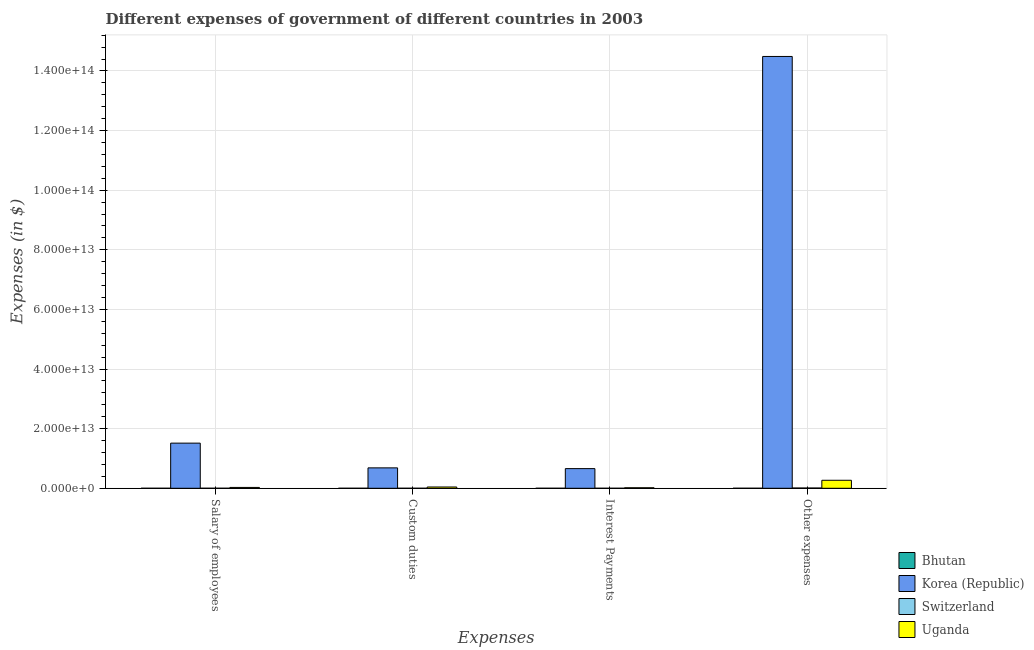How many different coloured bars are there?
Your answer should be compact. 4. Are the number of bars per tick equal to the number of legend labels?
Keep it short and to the point. Yes. How many bars are there on the 4th tick from the left?
Your answer should be compact. 4. How many bars are there on the 1st tick from the right?
Ensure brevity in your answer.  4. What is the label of the 4th group of bars from the left?
Your response must be concise. Other expenses. What is the amount spent on other expenses in Switzerland?
Offer a terse response. 8.66e+1. Across all countries, what is the maximum amount spent on salary of employees?
Keep it short and to the point. 1.51e+13. Across all countries, what is the minimum amount spent on salary of employees?
Provide a short and direct response. 1.95e+09. In which country was the amount spent on custom duties minimum?
Give a very brief answer. Bhutan. What is the total amount spent on custom duties in the graph?
Offer a very short reply. 7.28e+12. What is the difference between the amount spent on interest payments in Bhutan and that in Switzerland?
Provide a succinct answer. -3.12e+09. What is the difference between the amount spent on custom duties in Bhutan and the amount spent on salary of employees in Uganda?
Your response must be concise. -2.85e+11. What is the average amount spent on custom duties per country?
Your answer should be compact. 1.82e+12. What is the difference between the amount spent on interest payments and amount spent on other expenses in Bhutan?
Ensure brevity in your answer.  -5.20e+09. What is the ratio of the amount spent on other expenses in Korea (Republic) to that in Switzerland?
Ensure brevity in your answer.  1672.6. Is the amount spent on interest payments in Bhutan less than that in Korea (Republic)?
Keep it short and to the point. Yes. What is the difference between the highest and the second highest amount spent on salary of employees?
Give a very brief answer. 1.49e+13. What is the difference between the highest and the lowest amount spent on other expenses?
Offer a very short reply. 1.45e+14. Is the sum of the amount spent on salary of employees in Korea (Republic) and Bhutan greater than the maximum amount spent on custom duties across all countries?
Your response must be concise. Yes. What does the 3rd bar from the left in Other expenses represents?
Provide a succinct answer. Switzerland. What does the 2nd bar from the right in Other expenses represents?
Your answer should be very brief. Switzerland. How many bars are there?
Provide a short and direct response. 16. Are all the bars in the graph horizontal?
Provide a short and direct response. No. What is the difference between two consecutive major ticks on the Y-axis?
Your response must be concise. 2.00e+13. Are the values on the major ticks of Y-axis written in scientific E-notation?
Ensure brevity in your answer.  Yes. Does the graph contain grids?
Your answer should be very brief. Yes. Where does the legend appear in the graph?
Your response must be concise. Bottom right. How are the legend labels stacked?
Keep it short and to the point. Vertical. What is the title of the graph?
Ensure brevity in your answer.  Different expenses of government of different countries in 2003. Does "Lao PDR" appear as one of the legend labels in the graph?
Keep it short and to the point. No. What is the label or title of the X-axis?
Your answer should be compact. Expenses. What is the label or title of the Y-axis?
Provide a short and direct response. Expenses (in $). What is the Expenses (in $) in Bhutan in Salary of employees?
Offer a terse response. 1.95e+09. What is the Expenses (in $) in Korea (Republic) in Salary of employees?
Give a very brief answer. 1.51e+13. What is the Expenses (in $) of Switzerland in Salary of employees?
Your answer should be very brief. 5.68e+09. What is the Expenses (in $) of Uganda in Salary of employees?
Offer a terse response. 2.85e+11. What is the Expenses (in $) of Bhutan in Custom duties?
Give a very brief answer. 1.15e+08. What is the Expenses (in $) in Korea (Republic) in Custom duties?
Your response must be concise. 6.85e+12. What is the Expenses (in $) of Switzerland in Custom duties?
Offer a terse response. 9.75e+08. What is the Expenses (in $) in Uganda in Custom duties?
Your answer should be very brief. 4.30e+11. What is the Expenses (in $) in Bhutan in Interest Payments?
Provide a short and direct response. 1.69e+08. What is the Expenses (in $) in Korea (Republic) in Interest Payments?
Offer a terse response. 6.60e+12. What is the Expenses (in $) in Switzerland in Interest Payments?
Keep it short and to the point. 3.29e+09. What is the Expenses (in $) of Uganda in Interest Payments?
Provide a short and direct response. 1.74e+11. What is the Expenses (in $) in Bhutan in Other expenses?
Give a very brief answer. 5.37e+09. What is the Expenses (in $) in Korea (Republic) in Other expenses?
Offer a terse response. 1.45e+14. What is the Expenses (in $) of Switzerland in Other expenses?
Keep it short and to the point. 8.66e+1. What is the Expenses (in $) in Uganda in Other expenses?
Your response must be concise. 2.69e+12. Across all Expenses, what is the maximum Expenses (in $) in Bhutan?
Make the answer very short. 5.37e+09. Across all Expenses, what is the maximum Expenses (in $) of Korea (Republic)?
Your response must be concise. 1.45e+14. Across all Expenses, what is the maximum Expenses (in $) of Switzerland?
Offer a very short reply. 8.66e+1. Across all Expenses, what is the maximum Expenses (in $) of Uganda?
Offer a terse response. 2.69e+12. Across all Expenses, what is the minimum Expenses (in $) of Bhutan?
Offer a very short reply. 1.15e+08. Across all Expenses, what is the minimum Expenses (in $) in Korea (Republic)?
Keep it short and to the point. 6.60e+12. Across all Expenses, what is the minimum Expenses (in $) in Switzerland?
Provide a short and direct response. 9.75e+08. Across all Expenses, what is the minimum Expenses (in $) of Uganda?
Keep it short and to the point. 1.74e+11. What is the total Expenses (in $) in Bhutan in the graph?
Provide a succinct answer. 7.60e+09. What is the total Expenses (in $) of Korea (Republic) in the graph?
Offer a very short reply. 1.73e+14. What is the total Expenses (in $) of Switzerland in the graph?
Give a very brief answer. 9.66e+1. What is the total Expenses (in $) of Uganda in the graph?
Provide a succinct answer. 3.58e+12. What is the difference between the Expenses (in $) in Bhutan in Salary of employees and that in Custom duties?
Provide a short and direct response. 1.83e+09. What is the difference between the Expenses (in $) of Korea (Republic) in Salary of employees and that in Custom duties?
Your answer should be very brief. 8.30e+12. What is the difference between the Expenses (in $) of Switzerland in Salary of employees and that in Custom duties?
Make the answer very short. 4.70e+09. What is the difference between the Expenses (in $) in Uganda in Salary of employees and that in Custom duties?
Ensure brevity in your answer.  -1.45e+11. What is the difference between the Expenses (in $) in Bhutan in Salary of employees and that in Interest Payments?
Ensure brevity in your answer.  1.78e+09. What is the difference between the Expenses (in $) in Korea (Republic) in Salary of employees and that in Interest Payments?
Give a very brief answer. 8.55e+12. What is the difference between the Expenses (in $) of Switzerland in Salary of employees and that in Interest Payments?
Keep it short and to the point. 2.38e+09. What is the difference between the Expenses (in $) of Uganda in Salary of employees and that in Interest Payments?
Offer a very short reply. 1.11e+11. What is the difference between the Expenses (in $) in Bhutan in Salary of employees and that in Other expenses?
Give a very brief answer. -3.43e+09. What is the difference between the Expenses (in $) of Korea (Republic) in Salary of employees and that in Other expenses?
Make the answer very short. -1.30e+14. What is the difference between the Expenses (in $) in Switzerland in Salary of employees and that in Other expenses?
Your response must be concise. -8.09e+1. What is the difference between the Expenses (in $) of Uganda in Salary of employees and that in Other expenses?
Offer a very short reply. -2.40e+12. What is the difference between the Expenses (in $) of Bhutan in Custom duties and that in Interest Payments?
Offer a very short reply. -5.37e+07. What is the difference between the Expenses (in $) of Korea (Republic) in Custom duties and that in Interest Payments?
Ensure brevity in your answer.  2.50e+11. What is the difference between the Expenses (in $) in Switzerland in Custom duties and that in Interest Payments?
Your answer should be very brief. -2.32e+09. What is the difference between the Expenses (in $) of Uganda in Custom duties and that in Interest Payments?
Ensure brevity in your answer.  2.56e+11. What is the difference between the Expenses (in $) of Bhutan in Custom duties and that in Other expenses?
Give a very brief answer. -5.26e+09. What is the difference between the Expenses (in $) in Korea (Republic) in Custom duties and that in Other expenses?
Keep it short and to the point. -1.38e+14. What is the difference between the Expenses (in $) in Switzerland in Custom duties and that in Other expenses?
Offer a very short reply. -8.56e+1. What is the difference between the Expenses (in $) of Uganda in Custom duties and that in Other expenses?
Give a very brief answer. -2.26e+12. What is the difference between the Expenses (in $) in Bhutan in Interest Payments and that in Other expenses?
Keep it short and to the point. -5.20e+09. What is the difference between the Expenses (in $) of Korea (Republic) in Interest Payments and that in Other expenses?
Give a very brief answer. -1.38e+14. What is the difference between the Expenses (in $) of Switzerland in Interest Payments and that in Other expenses?
Ensure brevity in your answer.  -8.33e+1. What is the difference between the Expenses (in $) of Uganda in Interest Payments and that in Other expenses?
Offer a very short reply. -2.51e+12. What is the difference between the Expenses (in $) of Bhutan in Salary of employees and the Expenses (in $) of Korea (Republic) in Custom duties?
Your answer should be compact. -6.85e+12. What is the difference between the Expenses (in $) in Bhutan in Salary of employees and the Expenses (in $) in Switzerland in Custom duties?
Offer a very short reply. 9.72e+08. What is the difference between the Expenses (in $) of Bhutan in Salary of employees and the Expenses (in $) of Uganda in Custom duties?
Offer a very short reply. -4.28e+11. What is the difference between the Expenses (in $) in Korea (Republic) in Salary of employees and the Expenses (in $) in Switzerland in Custom duties?
Your answer should be compact. 1.51e+13. What is the difference between the Expenses (in $) of Korea (Republic) in Salary of employees and the Expenses (in $) of Uganda in Custom duties?
Provide a succinct answer. 1.47e+13. What is the difference between the Expenses (in $) in Switzerland in Salary of employees and the Expenses (in $) in Uganda in Custom duties?
Your answer should be very brief. -4.24e+11. What is the difference between the Expenses (in $) in Bhutan in Salary of employees and the Expenses (in $) in Korea (Republic) in Interest Payments?
Keep it short and to the point. -6.60e+12. What is the difference between the Expenses (in $) in Bhutan in Salary of employees and the Expenses (in $) in Switzerland in Interest Payments?
Your response must be concise. -1.35e+09. What is the difference between the Expenses (in $) in Bhutan in Salary of employees and the Expenses (in $) in Uganda in Interest Payments?
Offer a terse response. -1.72e+11. What is the difference between the Expenses (in $) in Korea (Republic) in Salary of employees and the Expenses (in $) in Switzerland in Interest Payments?
Provide a short and direct response. 1.51e+13. What is the difference between the Expenses (in $) in Korea (Republic) in Salary of employees and the Expenses (in $) in Uganda in Interest Payments?
Your answer should be compact. 1.50e+13. What is the difference between the Expenses (in $) in Switzerland in Salary of employees and the Expenses (in $) in Uganda in Interest Payments?
Provide a short and direct response. -1.68e+11. What is the difference between the Expenses (in $) in Bhutan in Salary of employees and the Expenses (in $) in Korea (Republic) in Other expenses?
Your response must be concise. -1.45e+14. What is the difference between the Expenses (in $) of Bhutan in Salary of employees and the Expenses (in $) of Switzerland in Other expenses?
Ensure brevity in your answer.  -8.47e+1. What is the difference between the Expenses (in $) in Bhutan in Salary of employees and the Expenses (in $) in Uganda in Other expenses?
Offer a terse response. -2.69e+12. What is the difference between the Expenses (in $) in Korea (Republic) in Salary of employees and the Expenses (in $) in Switzerland in Other expenses?
Provide a succinct answer. 1.51e+13. What is the difference between the Expenses (in $) in Korea (Republic) in Salary of employees and the Expenses (in $) in Uganda in Other expenses?
Keep it short and to the point. 1.25e+13. What is the difference between the Expenses (in $) of Switzerland in Salary of employees and the Expenses (in $) of Uganda in Other expenses?
Your answer should be compact. -2.68e+12. What is the difference between the Expenses (in $) of Bhutan in Custom duties and the Expenses (in $) of Korea (Republic) in Interest Payments?
Keep it short and to the point. -6.60e+12. What is the difference between the Expenses (in $) of Bhutan in Custom duties and the Expenses (in $) of Switzerland in Interest Payments?
Make the answer very short. -3.18e+09. What is the difference between the Expenses (in $) of Bhutan in Custom duties and the Expenses (in $) of Uganda in Interest Payments?
Your answer should be very brief. -1.74e+11. What is the difference between the Expenses (in $) in Korea (Republic) in Custom duties and the Expenses (in $) in Switzerland in Interest Payments?
Make the answer very short. 6.84e+12. What is the difference between the Expenses (in $) in Korea (Republic) in Custom duties and the Expenses (in $) in Uganda in Interest Payments?
Keep it short and to the point. 6.67e+12. What is the difference between the Expenses (in $) in Switzerland in Custom duties and the Expenses (in $) in Uganda in Interest Payments?
Keep it short and to the point. -1.73e+11. What is the difference between the Expenses (in $) of Bhutan in Custom duties and the Expenses (in $) of Korea (Republic) in Other expenses?
Ensure brevity in your answer.  -1.45e+14. What is the difference between the Expenses (in $) of Bhutan in Custom duties and the Expenses (in $) of Switzerland in Other expenses?
Provide a short and direct response. -8.65e+1. What is the difference between the Expenses (in $) of Bhutan in Custom duties and the Expenses (in $) of Uganda in Other expenses?
Your answer should be very brief. -2.69e+12. What is the difference between the Expenses (in $) in Korea (Republic) in Custom duties and the Expenses (in $) in Switzerland in Other expenses?
Your answer should be very brief. 6.76e+12. What is the difference between the Expenses (in $) of Korea (Republic) in Custom duties and the Expenses (in $) of Uganda in Other expenses?
Make the answer very short. 4.16e+12. What is the difference between the Expenses (in $) of Switzerland in Custom duties and the Expenses (in $) of Uganda in Other expenses?
Ensure brevity in your answer.  -2.69e+12. What is the difference between the Expenses (in $) of Bhutan in Interest Payments and the Expenses (in $) of Korea (Republic) in Other expenses?
Your answer should be compact. -1.45e+14. What is the difference between the Expenses (in $) of Bhutan in Interest Payments and the Expenses (in $) of Switzerland in Other expenses?
Your response must be concise. -8.64e+1. What is the difference between the Expenses (in $) in Bhutan in Interest Payments and the Expenses (in $) in Uganda in Other expenses?
Your response must be concise. -2.69e+12. What is the difference between the Expenses (in $) in Korea (Republic) in Interest Payments and the Expenses (in $) in Switzerland in Other expenses?
Keep it short and to the point. 6.51e+12. What is the difference between the Expenses (in $) of Korea (Republic) in Interest Payments and the Expenses (in $) of Uganda in Other expenses?
Give a very brief answer. 3.91e+12. What is the difference between the Expenses (in $) in Switzerland in Interest Payments and the Expenses (in $) in Uganda in Other expenses?
Your answer should be compact. -2.68e+12. What is the average Expenses (in $) in Bhutan per Expenses?
Offer a terse response. 1.90e+09. What is the average Expenses (in $) in Korea (Republic) per Expenses?
Give a very brief answer. 4.34e+13. What is the average Expenses (in $) of Switzerland per Expenses?
Make the answer very short. 2.41e+1. What is the average Expenses (in $) of Uganda per Expenses?
Offer a terse response. 8.94e+11. What is the difference between the Expenses (in $) of Bhutan and Expenses (in $) of Korea (Republic) in Salary of employees?
Give a very brief answer. -1.51e+13. What is the difference between the Expenses (in $) in Bhutan and Expenses (in $) in Switzerland in Salary of employees?
Keep it short and to the point. -3.73e+09. What is the difference between the Expenses (in $) of Bhutan and Expenses (in $) of Uganda in Salary of employees?
Your answer should be very brief. -2.83e+11. What is the difference between the Expenses (in $) of Korea (Republic) and Expenses (in $) of Switzerland in Salary of employees?
Provide a short and direct response. 1.51e+13. What is the difference between the Expenses (in $) in Korea (Republic) and Expenses (in $) in Uganda in Salary of employees?
Offer a terse response. 1.49e+13. What is the difference between the Expenses (in $) in Switzerland and Expenses (in $) in Uganda in Salary of employees?
Ensure brevity in your answer.  -2.79e+11. What is the difference between the Expenses (in $) in Bhutan and Expenses (in $) in Korea (Republic) in Custom duties?
Provide a succinct answer. -6.85e+12. What is the difference between the Expenses (in $) of Bhutan and Expenses (in $) of Switzerland in Custom duties?
Your answer should be compact. -8.60e+08. What is the difference between the Expenses (in $) of Bhutan and Expenses (in $) of Uganda in Custom duties?
Your response must be concise. -4.30e+11. What is the difference between the Expenses (in $) in Korea (Republic) and Expenses (in $) in Switzerland in Custom duties?
Provide a short and direct response. 6.85e+12. What is the difference between the Expenses (in $) of Korea (Republic) and Expenses (in $) of Uganda in Custom duties?
Your response must be concise. 6.42e+12. What is the difference between the Expenses (in $) in Switzerland and Expenses (in $) in Uganda in Custom duties?
Ensure brevity in your answer.  -4.29e+11. What is the difference between the Expenses (in $) in Bhutan and Expenses (in $) in Korea (Republic) in Interest Payments?
Give a very brief answer. -6.60e+12. What is the difference between the Expenses (in $) of Bhutan and Expenses (in $) of Switzerland in Interest Payments?
Provide a short and direct response. -3.12e+09. What is the difference between the Expenses (in $) of Bhutan and Expenses (in $) of Uganda in Interest Payments?
Your answer should be compact. -1.74e+11. What is the difference between the Expenses (in $) in Korea (Republic) and Expenses (in $) in Switzerland in Interest Payments?
Keep it short and to the point. 6.59e+12. What is the difference between the Expenses (in $) of Korea (Republic) and Expenses (in $) of Uganda in Interest Payments?
Your answer should be compact. 6.42e+12. What is the difference between the Expenses (in $) of Switzerland and Expenses (in $) of Uganda in Interest Payments?
Provide a succinct answer. -1.71e+11. What is the difference between the Expenses (in $) in Bhutan and Expenses (in $) in Korea (Republic) in Other expenses?
Give a very brief answer. -1.45e+14. What is the difference between the Expenses (in $) in Bhutan and Expenses (in $) in Switzerland in Other expenses?
Your answer should be compact. -8.12e+1. What is the difference between the Expenses (in $) in Bhutan and Expenses (in $) in Uganda in Other expenses?
Offer a terse response. -2.68e+12. What is the difference between the Expenses (in $) of Korea (Republic) and Expenses (in $) of Switzerland in Other expenses?
Provide a short and direct response. 1.45e+14. What is the difference between the Expenses (in $) in Korea (Republic) and Expenses (in $) in Uganda in Other expenses?
Your answer should be very brief. 1.42e+14. What is the difference between the Expenses (in $) of Switzerland and Expenses (in $) of Uganda in Other expenses?
Give a very brief answer. -2.60e+12. What is the ratio of the Expenses (in $) of Bhutan in Salary of employees to that in Custom duties?
Your response must be concise. 16.91. What is the ratio of the Expenses (in $) in Korea (Republic) in Salary of employees to that in Custom duties?
Make the answer very short. 2.21. What is the ratio of the Expenses (in $) in Switzerland in Salary of employees to that in Custom duties?
Keep it short and to the point. 5.82. What is the ratio of the Expenses (in $) of Uganda in Salary of employees to that in Custom duties?
Ensure brevity in your answer.  0.66. What is the ratio of the Expenses (in $) in Bhutan in Salary of employees to that in Interest Payments?
Ensure brevity in your answer.  11.53. What is the ratio of the Expenses (in $) in Korea (Republic) in Salary of employees to that in Interest Payments?
Offer a terse response. 2.3. What is the ratio of the Expenses (in $) in Switzerland in Salary of employees to that in Interest Payments?
Keep it short and to the point. 1.72. What is the ratio of the Expenses (in $) in Uganda in Salary of employees to that in Interest Payments?
Your response must be concise. 1.64. What is the ratio of the Expenses (in $) in Bhutan in Salary of employees to that in Other expenses?
Your answer should be compact. 0.36. What is the ratio of the Expenses (in $) of Korea (Republic) in Salary of employees to that in Other expenses?
Give a very brief answer. 0.1. What is the ratio of the Expenses (in $) of Switzerland in Salary of employees to that in Other expenses?
Provide a succinct answer. 0.07. What is the ratio of the Expenses (in $) of Uganda in Salary of employees to that in Other expenses?
Offer a very short reply. 0.11. What is the ratio of the Expenses (in $) of Bhutan in Custom duties to that in Interest Payments?
Make the answer very short. 0.68. What is the ratio of the Expenses (in $) in Korea (Republic) in Custom duties to that in Interest Payments?
Your answer should be compact. 1.04. What is the ratio of the Expenses (in $) in Switzerland in Custom duties to that in Interest Payments?
Your answer should be compact. 0.3. What is the ratio of the Expenses (in $) of Uganda in Custom duties to that in Interest Payments?
Your answer should be compact. 2.47. What is the ratio of the Expenses (in $) in Bhutan in Custom duties to that in Other expenses?
Offer a very short reply. 0.02. What is the ratio of the Expenses (in $) in Korea (Republic) in Custom duties to that in Other expenses?
Your response must be concise. 0.05. What is the ratio of the Expenses (in $) in Switzerland in Custom duties to that in Other expenses?
Ensure brevity in your answer.  0.01. What is the ratio of the Expenses (in $) in Uganda in Custom duties to that in Other expenses?
Your response must be concise. 0.16. What is the ratio of the Expenses (in $) of Bhutan in Interest Payments to that in Other expenses?
Provide a short and direct response. 0.03. What is the ratio of the Expenses (in $) in Korea (Republic) in Interest Payments to that in Other expenses?
Make the answer very short. 0.05. What is the ratio of the Expenses (in $) of Switzerland in Interest Payments to that in Other expenses?
Your answer should be very brief. 0.04. What is the ratio of the Expenses (in $) of Uganda in Interest Payments to that in Other expenses?
Offer a very short reply. 0.06. What is the difference between the highest and the second highest Expenses (in $) in Bhutan?
Provide a succinct answer. 3.43e+09. What is the difference between the highest and the second highest Expenses (in $) in Korea (Republic)?
Ensure brevity in your answer.  1.30e+14. What is the difference between the highest and the second highest Expenses (in $) of Switzerland?
Make the answer very short. 8.09e+1. What is the difference between the highest and the second highest Expenses (in $) in Uganda?
Provide a succinct answer. 2.26e+12. What is the difference between the highest and the lowest Expenses (in $) of Bhutan?
Keep it short and to the point. 5.26e+09. What is the difference between the highest and the lowest Expenses (in $) in Korea (Republic)?
Your response must be concise. 1.38e+14. What is the difference between the highest and the lowest Expenses (in $) of Switzerland?
Ensure brevity in your answer.  8.56e+1. What is the difference between the highest and the lowest Expenses (in $) of Uganda?
Your response must be concise. 2.51e+12. 